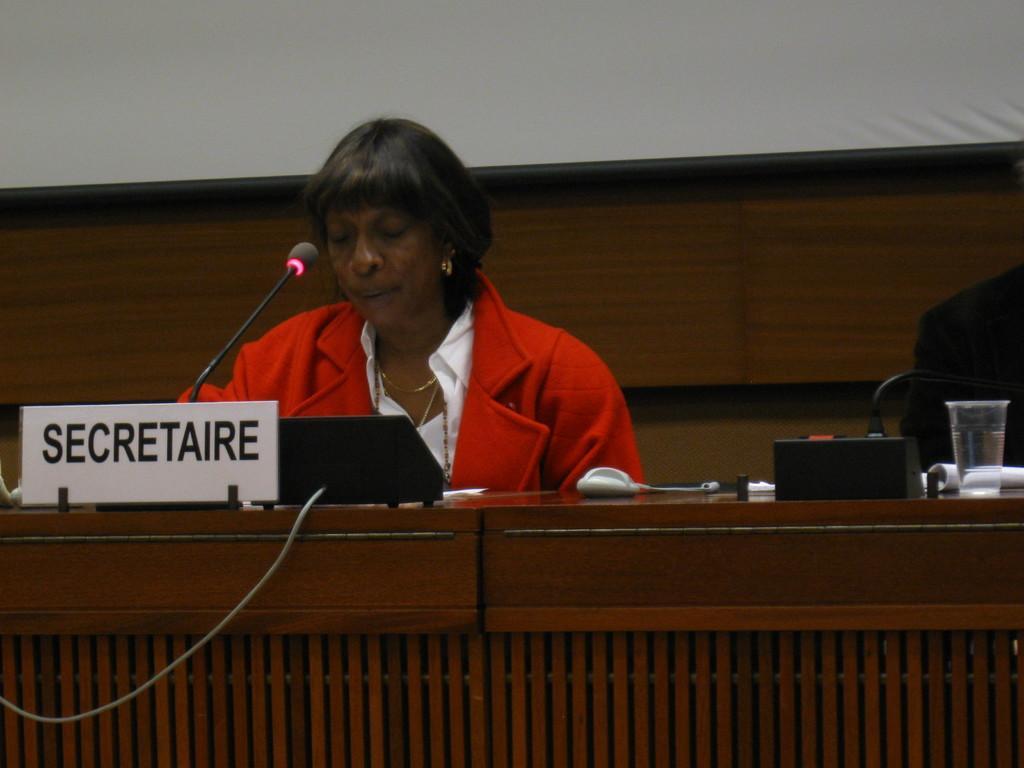Could you give a brief overview of what you see in this image? In this image there is one person who is sitting and talking, in front of her there is a table. On the table there is a name board, mike, glass, book and some objects. And on the right side there is another person sitting, and in the background there is a wooden board and wall. 